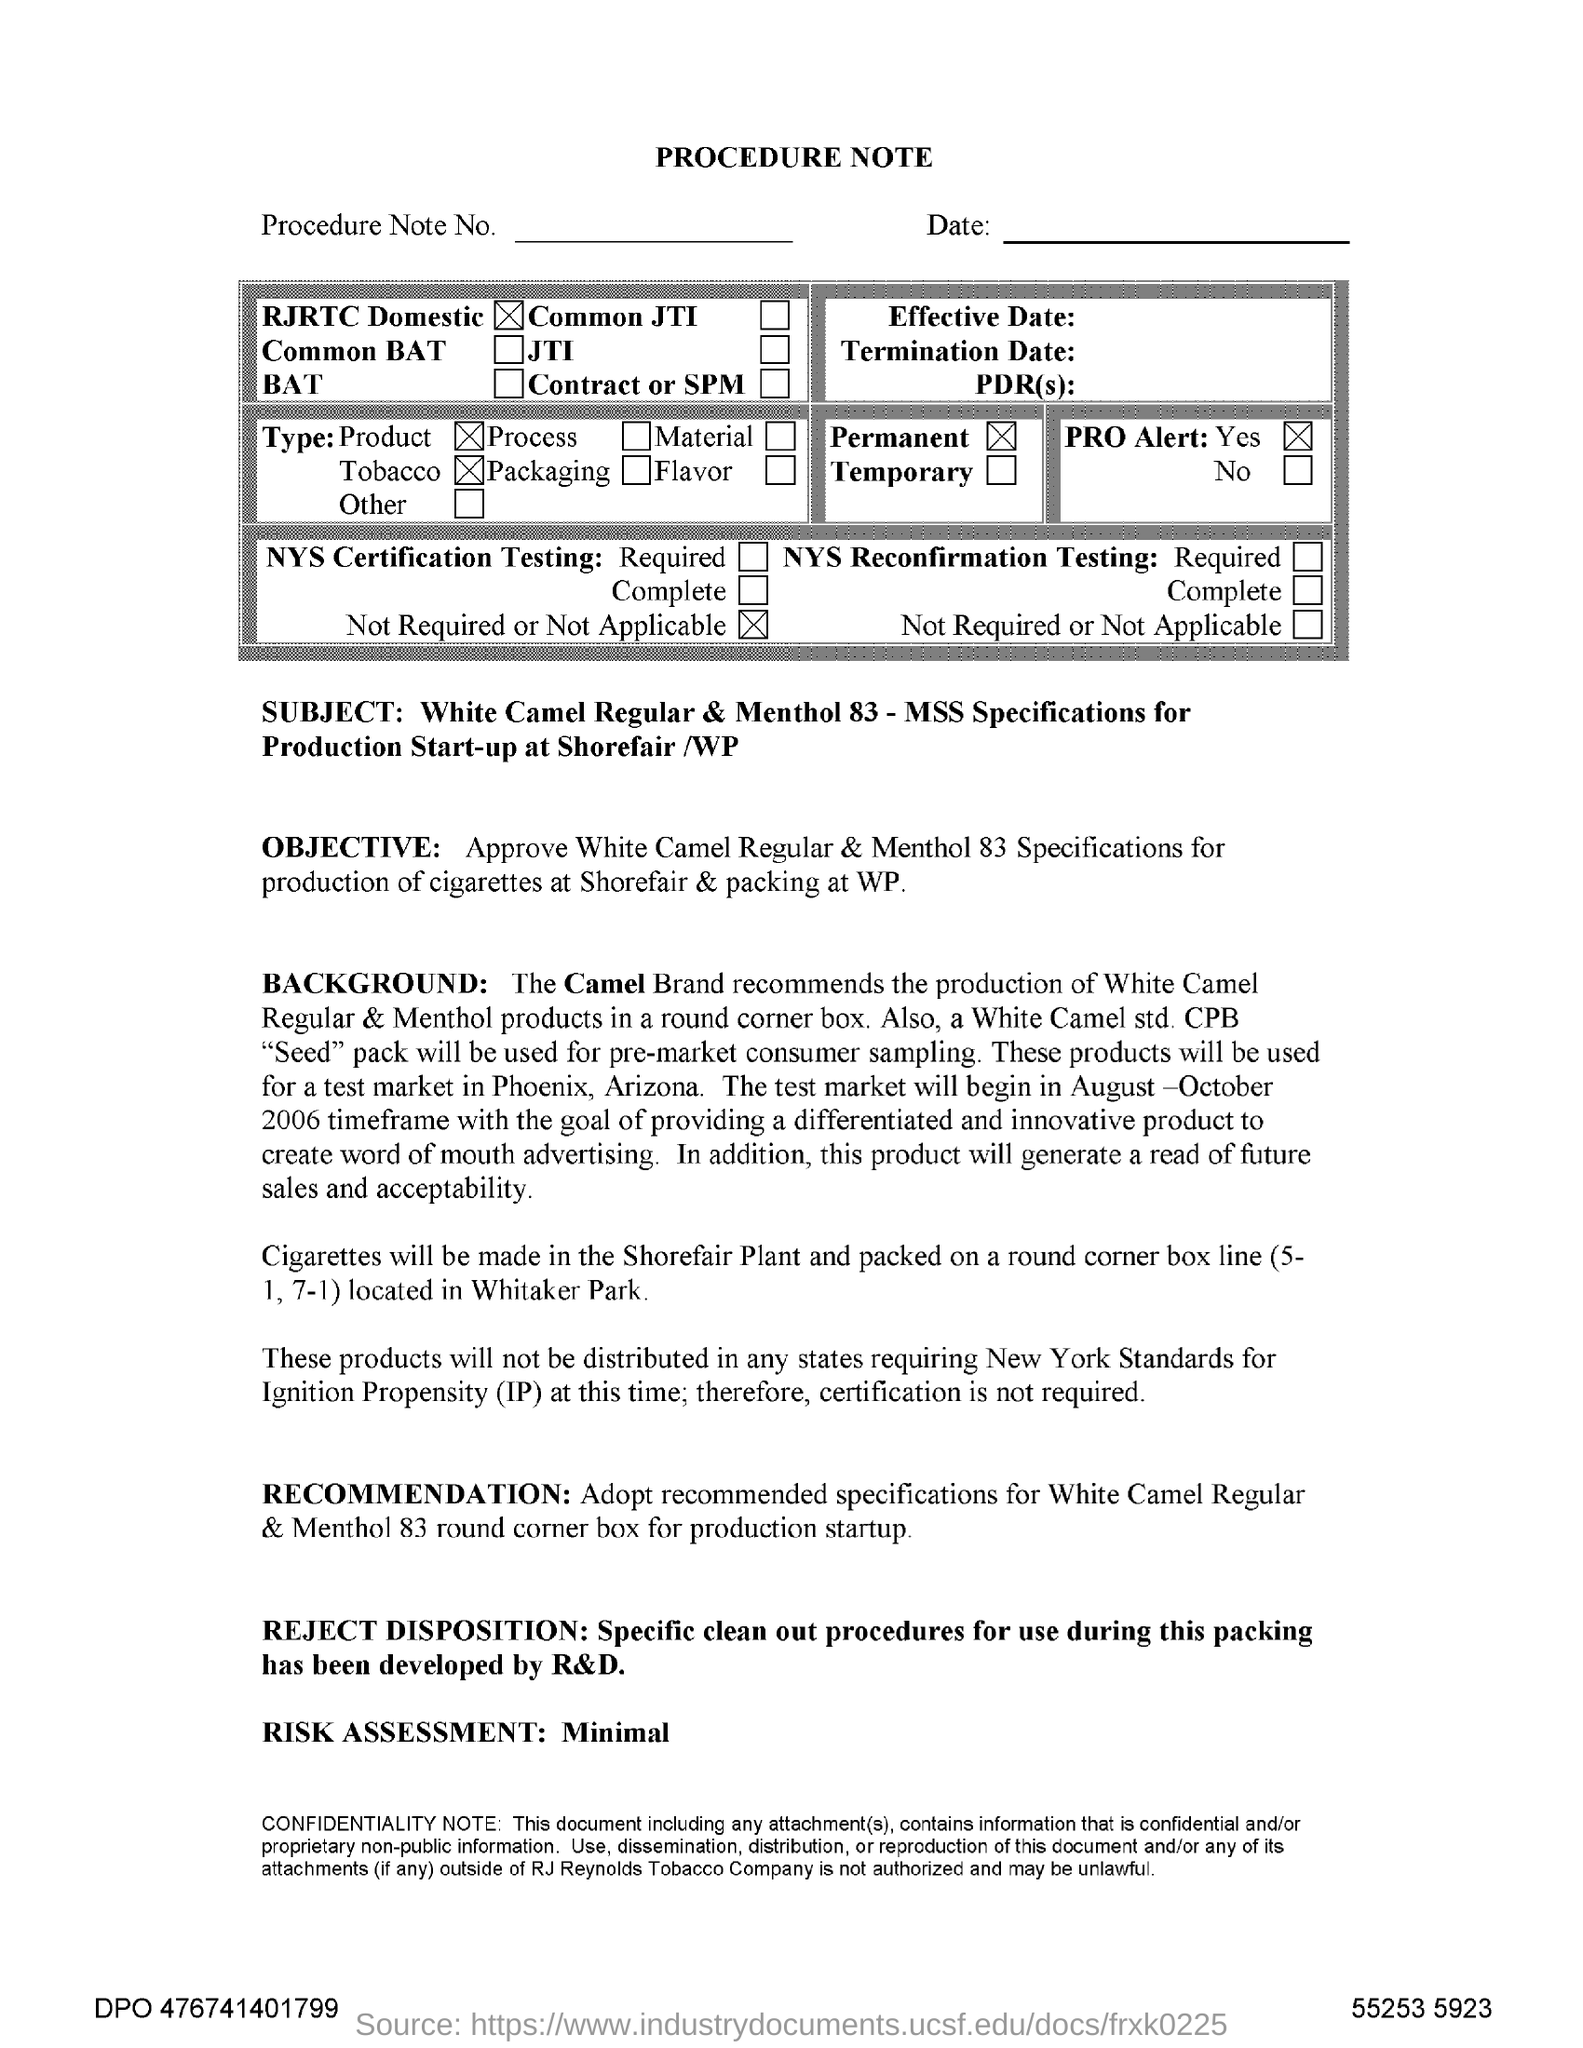Highlight a few significant elements in this photo. The subject mentioned in the procedure note is the white camel regular & menthol 83 - mss specifications for the production start-up at Shorefair /wp. Ignition propensity is the full form of IP. 